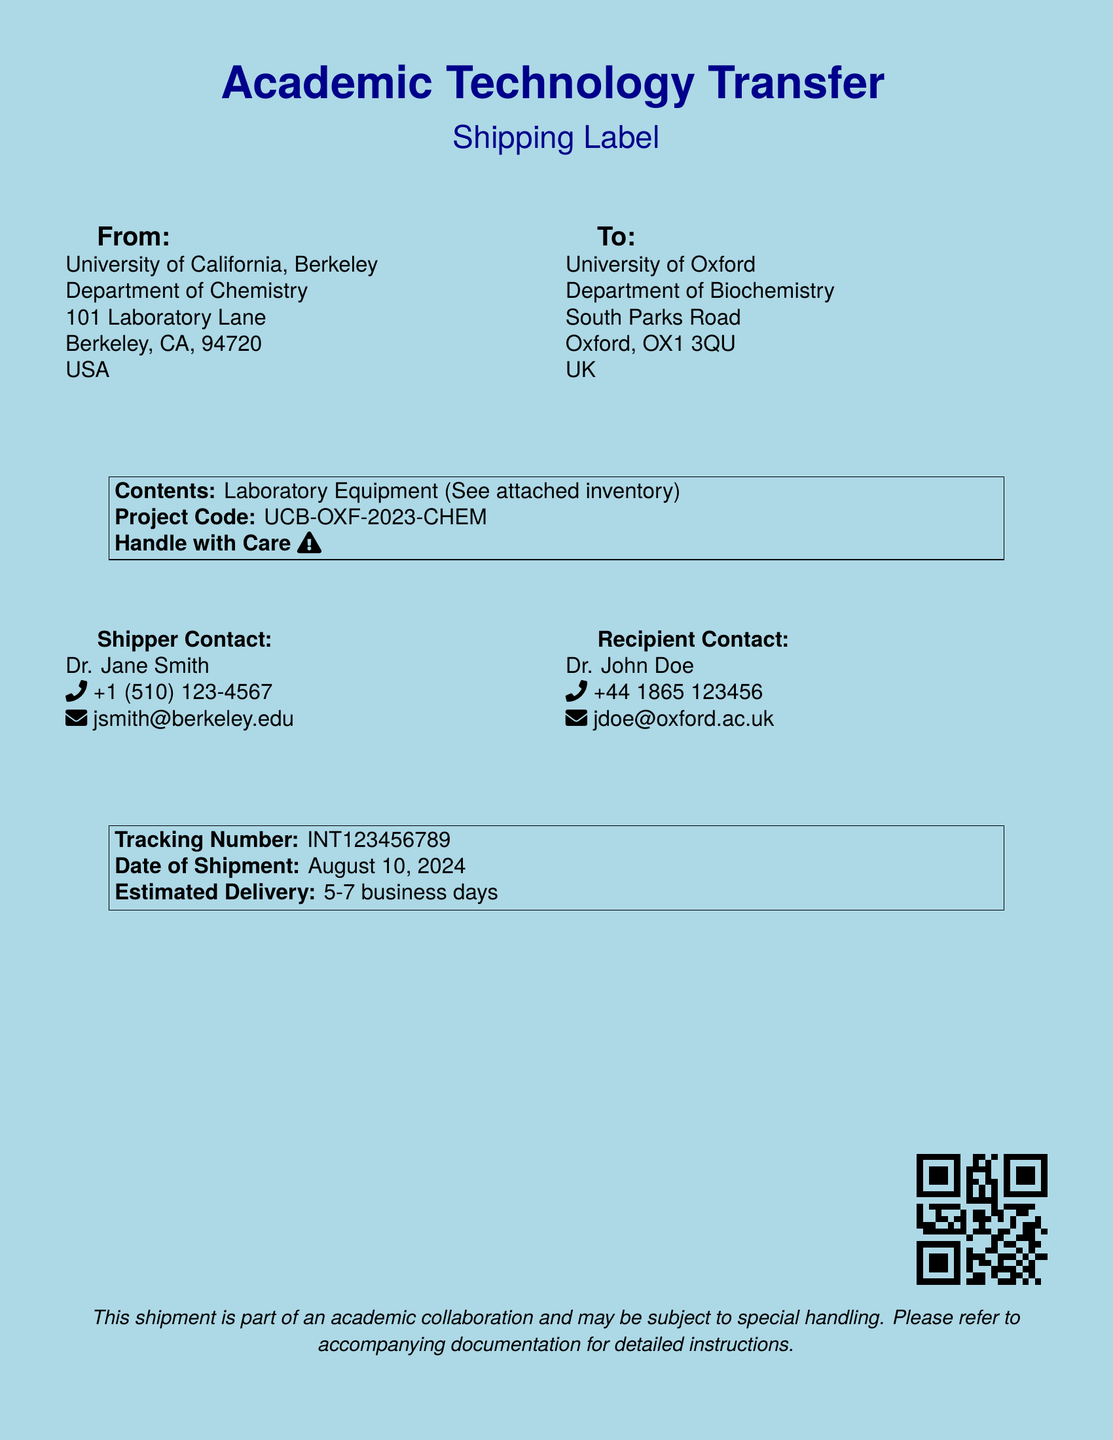What is the shipment's project code? The project code is specified in the contents section of the document.
Answer: UCB-OXF-2023-CHEM Who is the shipper contact? The shipper contact is listed under the "Shipper Contact" section.
Answer: Dr. Jane Smith What is the recipient's location? The recipient's location is the address provided under the "To" section.
Answer: University of Oxford, Department of Biochemistry, South Parks Road, Oxford, OX1 3QU, UK What is the phone number of the recipient contact? The phone number is noted next to the recipient contact's name.
Answer: +44 1865 123456 How many days is the estimated delivery? The estimated delivery is mentioned in the shipping information section.
Answer: 5-7 business days What does the shipment contain? The contents of the shipment are explicitly listed in the contents section.
Answer: Laboratory Equipment What color is the background of the document? The background color is noted at the beginning of the document.
Answer: Light blue What is the tracking number? The tracking number is provided in the last boxed section of the document.
Answer: INT123456789 What is the significance of the warning icon? The warning icon indicates a special instruction related to the handling of the shipment.
Answer: Handle with Care 